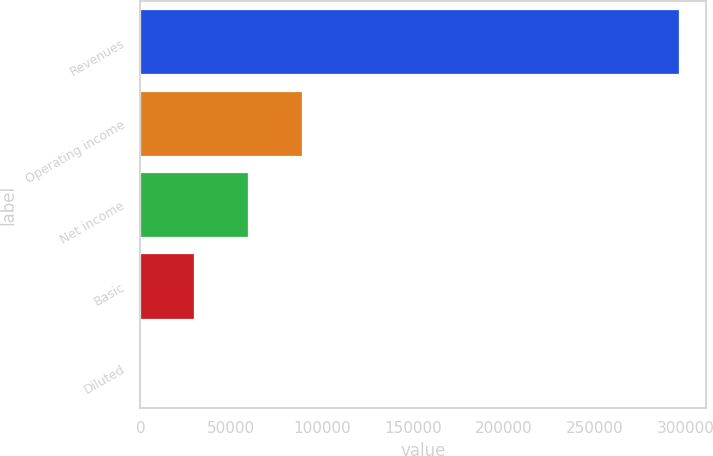Convert chart. <chart><loc_0><loc_0><loc_500><loc_500><bar_chart><fcel>Revenues<fcel>Operating income<fcel>Net income<fcel>Basic<fcel>Diluted<nl><fcel>296122<fcel>88836.7<fcel>59224.6<fcel>29612.4<fcel>0.2<nl></chart> 